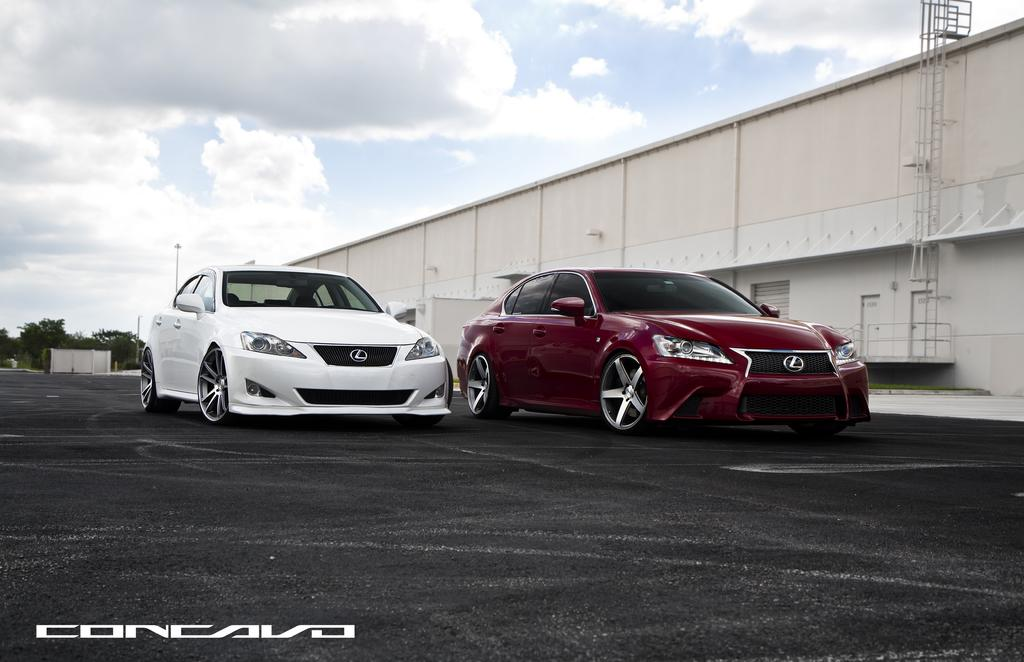What is the main subject in the center of the image? There are cars in the center of the image. What colors are the cars? The cars are red and white in color. What can be seen in the background of the image? There are trees in the background of the image. What structure is located on the right side of the image? There is a shed on the right side of the image. How would you describe the sky in the image? The sky is cloudy in the image. What type of necklace is the mother wearing in the image? There is no mother or necklace present in the image; it features cars, trees, and a shed. What time is displayed on the watch in the image? There is no watch present in the image. 